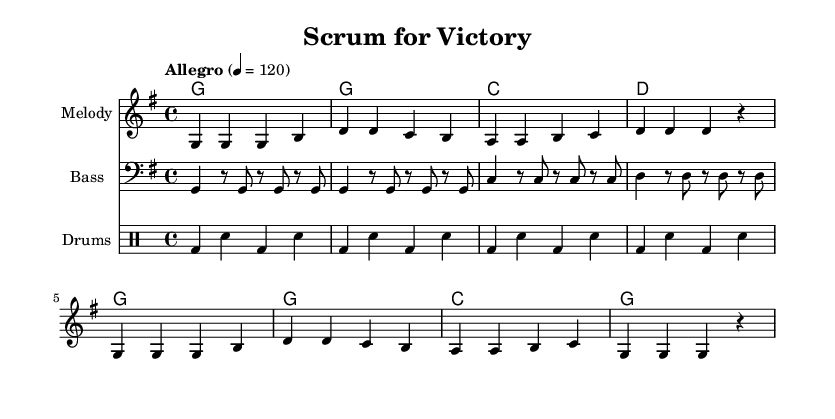What is the key signature of this music? The key signature is indicated by the sharp or flat symbols shown at the beginning of the staff. In this score, there are no sharps or flats present, making it G major.
Answer: G major What is the time signature of this music? The time signature is found at the beginning of the score and indicates the number of beats in each measure. Here, it is shown as 4/4, meaning there are four beats per measure.
Answer: 4/4 What is the tempo marking of this music? The tempo marking is indicated in the header section where it states "Allegro 4 = 120". This indicates a fast tempo of 120 beats per minute.
Answer: 120 How many measures are there in the melody? To determine the number of measures, we can count the occurrences of vertical lines (bar lines) in the melody section. There are a total of 8 measures present.
Answer: 8 What are the chord names used in this piece? The chord names can be found in the chordNames section of the score. They are listed in order as G, C, and D.
Answer: G, C, D What is the primary theme of the lyrics? The lyrics indicate a focus on teamwork and determination in rugby, reflecting a passionate call to action for players to give their all during a match.
Answer: Teamwork and determination How do the drums contribute to the overall feel of the song? The drum pattern, consisting of bass and snare hits, provides a driving rhythm that supports the energetic and competitive nature of the song, enhancing its rugby theme.
Answer: Driving rhythm 